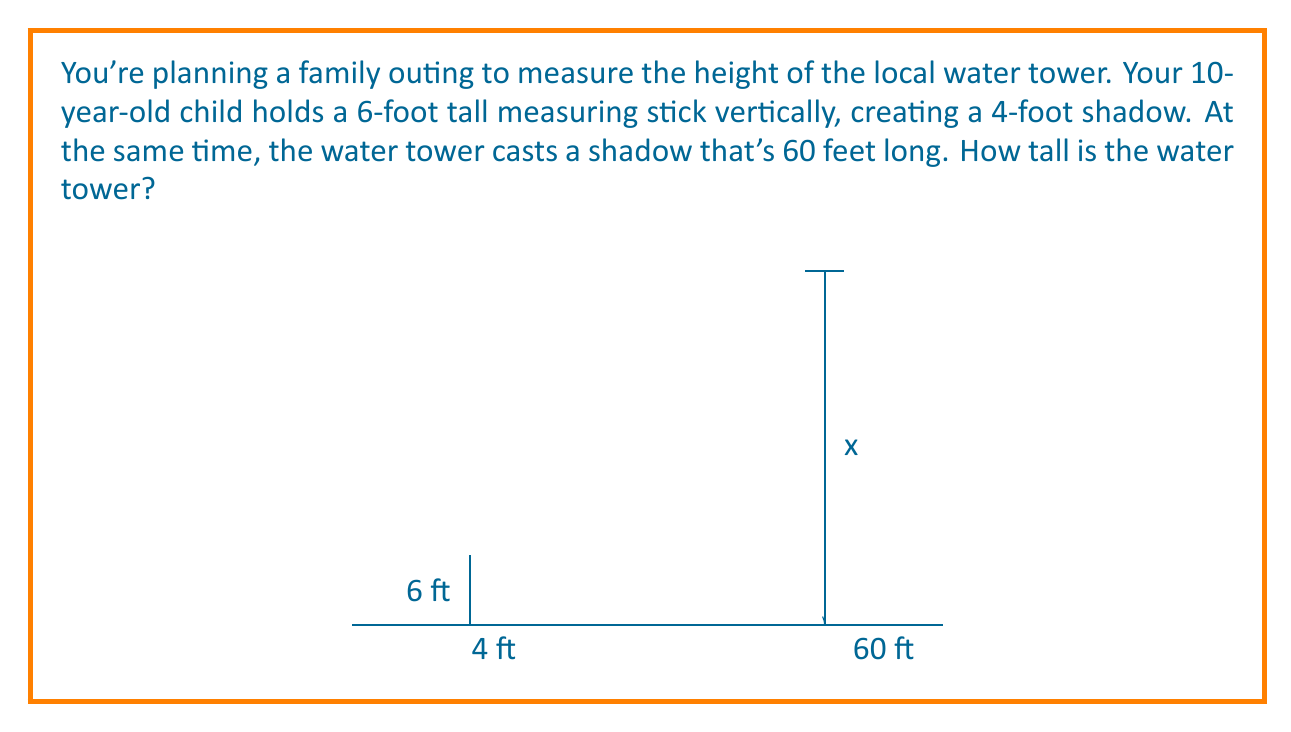Help me with this question. Let's solve this step-by-step using similar triangles:

1) First, we need to recognize that the triangle formed by the measuring stick and its shadow is similar to the triangle formed by the water tower and its shadow. This is because the sun's rays are essentially parallel, creating similar right triangles.

2) Let's define our variables:
   - Height of the stick: $h_1 = 6$ feet
   - Length of stick's shadow: $s_1 = 4$ feet
   - Length of water tower's shadow: $s_2 = 60$ feet
   - Height of water tower: $h_2 = x$ (unknown)

3) In similar triangles, the ratios of corresponding sides are equal. We can set up this proportion:

   $$\frac{h_1}{s_1} = \frac{h_2}{s_2}$$

4) Substituting our known values:

   $$\frac{6}{4} = \frac{x}{60}$$

5) Cross multiply:

   $$6 \cdot 60 = 4x$$

6) Simplify:

   $$360 = 4x$$

7) Solve for $x$:

   $$x = \frac{360}{4} = 90$$

Therefore, the water tower is 90 feet tall.
Answer: 90 feet 